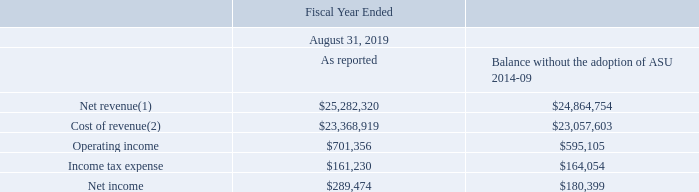The following table presents the effect of the adoption of the new revenue guidance on the Consolidated Statement of Operations for the fiscal year ended August 31, 2019 (in thousands):
(1) Differences primarily relate to the timing of revenue recognition for over-time customers and to the recovery of fulfillment costs.
(2) Differences primarily relate to the timing of cost recognition for over-time customers and the recognition of fulfillment costs.
What do the differences in amount of net revenue between as reported and balance without the adoption of ASU 2014-09 primarily relate to? The timing of revenue recognition for over-time customers and to the recovery of fulfillment costs. What was the net revenue as reported?
Answer scale should be: thousand. $25,282,320. What was the operating income as reported?
Answer scale should be: thousand. $701,356. What was the difference between net revenue and cost of revenue as reported?
Answer scale should be: thousand. 25,282,320-23,368,919
Answer: 1913401. What was the operating income balance without the adoption of ASU 2014-09 as a ratio of the amount as reported?
Answer scale should be: percent. 595,105/701,356
Answer: 0.85. What was the difference in the net income between the amount as reported and the balance without the adoption of ASU 2014-09?
Answer scale should be: thousand. 289,474-180,399
Answer: 109075. 